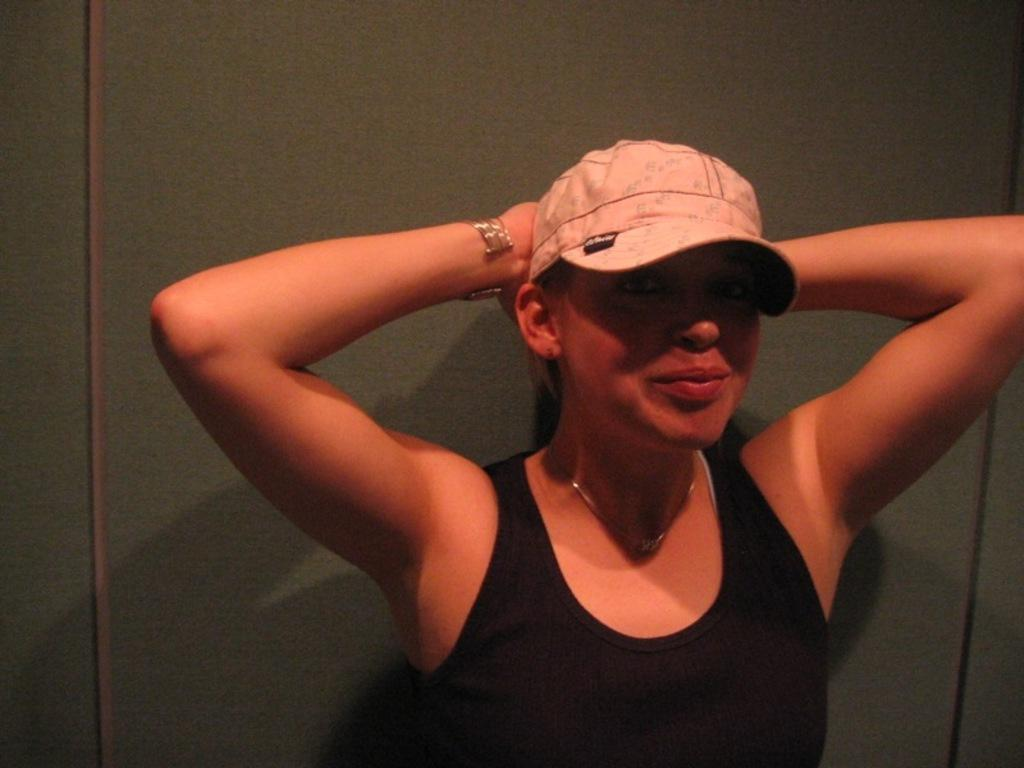Who is in the picture? There is a woman in the picture. What is the woman doing in the image? The woman is smiling. What is the woman wearing on her head? The woman is wearing a cap. What can be seen in the background of the image? There is a wall visible in the background of the image. What type of ring can be seen on the woman's finger in the image? There is no ring visible on the woman's finger in the image. What kind of cream is being applied to the woman's face in the image? There is no cream being applied to the woman's face in the image. 